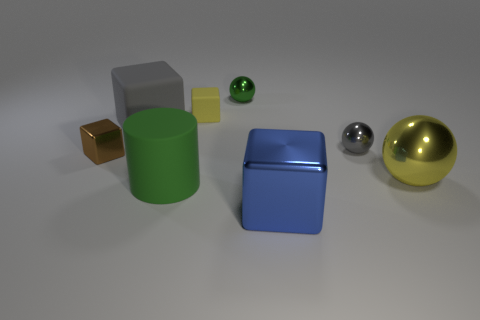There is a thing that is the same color as the large metallic ball; what material is it?
Make the answer very short. Rubber. What number of other things are there of the same color as the cylinder?
Offer a very short reply. 1. Are there any other things that have the same material as the yellow cube?
Ensure brevity in your answer.  Yes. Are there more matte cylinders that are behind the tiny gray metal object than tiny purple cubes?
Provide a succinct answer. No. Does the big shiny cube have the same color as the tiny matte thing?
Give a very brief answer. No. How many other gray things have the same shape as the small matte object?
Your response must be concise. 1. What size is the gray object that is made of the same material as the small green sphere?
Provide a short and direct response. Small. What is the color of the small thing that is in front of the gray cube and to the right of the small yellow matte thing?
Make the answer very short. Gray. How many gray balls are the same size as the yellow metal ball?
Your answer should be very brief. 0. The object that is the same color as the big cylinder is what size?
Ensure brevity in your answer.  Small. 